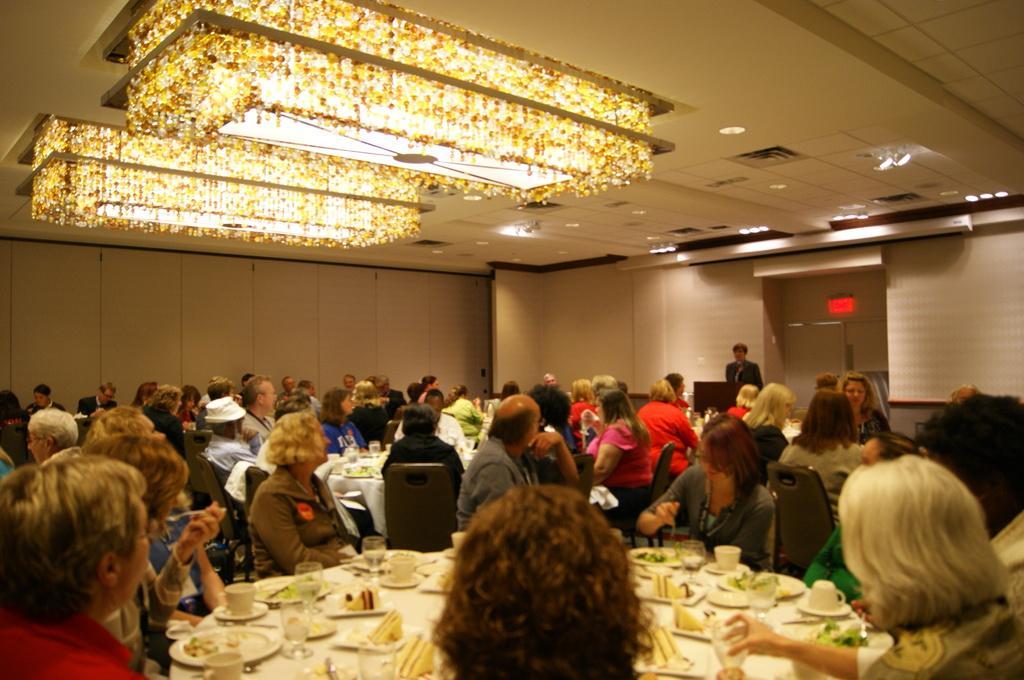Please provide a concise description of this image. This is completely an inside view picture. Here we can see a decorative ceiling light. Here we can see one person standing in front of a podium. Here we can see all the persons on the chairs in front of a table and on the table we can see glasses, cups , saucers and plates in which there is a food. We can see tissue papers. 